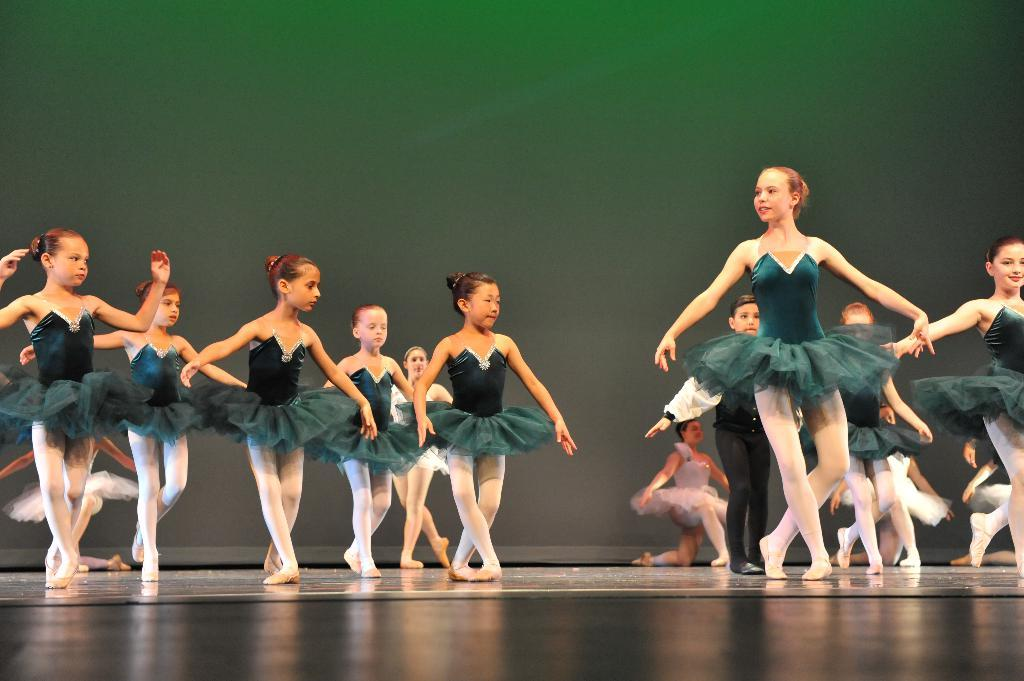What is happening in the image? There are many girls in the image, and they are performing a dance. What are the girls wearing? Most of the girls are wearing green frocks. What type of zinc is being used to paint the girls' faces in the image? There is no mention of zinc or face painting in the image, so it cannot be determined if any zinc is being used. 